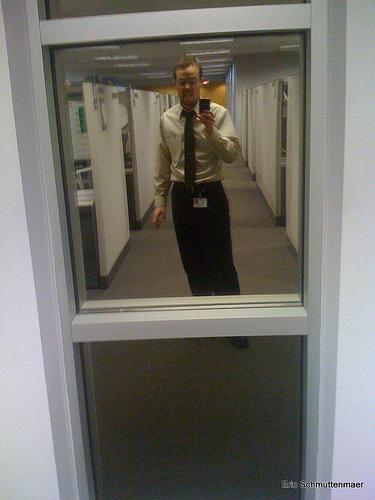What kind of identification is the man wearing? The man is wearing a white identification badge or name tag. What is the man wearing around his neck? The man is wearing a dark necktie. Provide a description of the exit sign in the image. The exit sign is at the end of the hallway and has a height and width of 15. What type of lighting is present in the office? There are five fluorescent lights in the ceiling of the office. What is the man sticking out while taking his self-portrait? The man is sticking out his tongue. Identify the main activity taking place in the image. A man is taking a self portrait in his office cubicle. Mention any noticeable paper or adornment on the cubicle wall. There is a blue paper on the cubicle wall. What kind of shirt is the man wearing? The man is wearing a white, light-colored button-up shirt with a collar and long sleeves. Describe the footwear visible in the image. A black shoe is visible in the image, with width 39 and height 39. Describe what the man is holding and what he's doing with it. The man is holding a black cell phone and using it to take a picture of himself. 